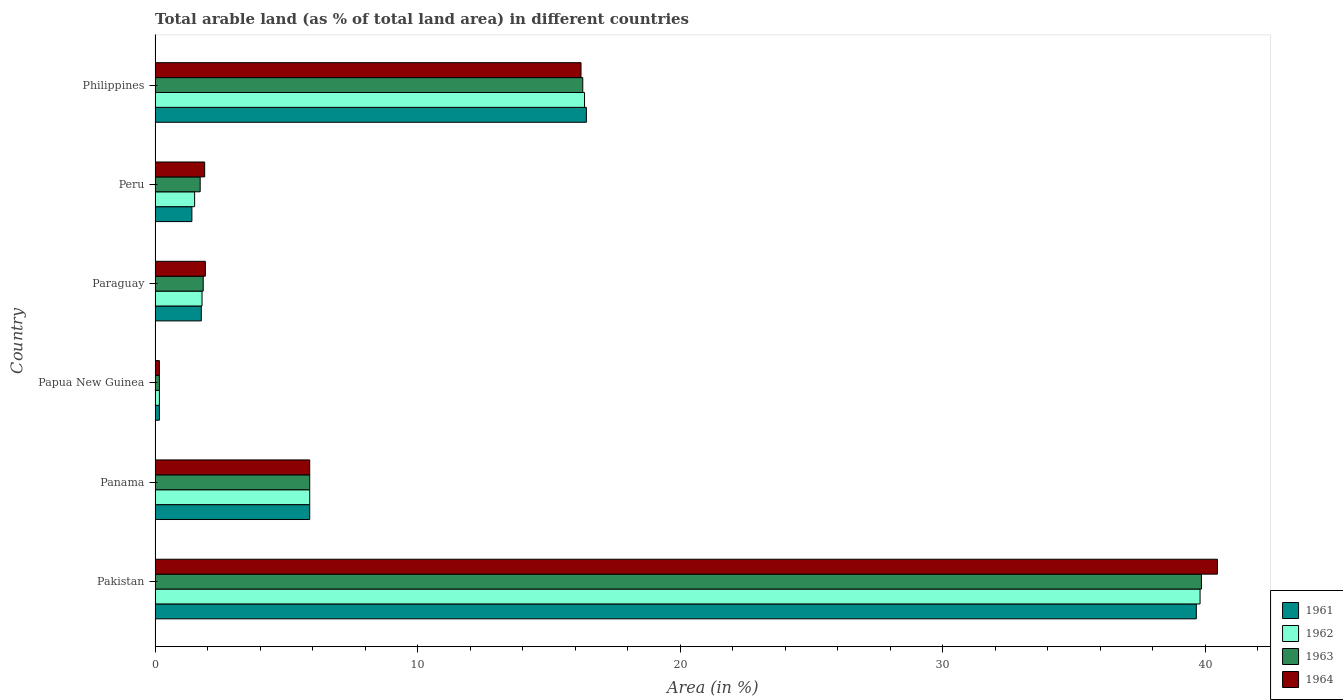How many groups of bars are there?
Ensure brevity in your answer.  6. Are the number of bars per tick equal to the number of legend labels?
Keep it short and to the point. Yes. How many bars are there on the 2nd tick from the bottom?
Ensure brevity in your answer.  4. What is the label of the 4th group of bars from the top?
Give a very brief answer. Papua New Guinea. In how many cases, is the number of bars for a given country not equal to the number of legend labels?
Offer a terse response. 0. What is the percentage of arable land in 1964 in Papua New Guinea?
Your answer should be compact. 0.17. Across all countries, what is the maximum percentage of arable land in 1964?
Provide a succinct answer. 40.47. Across all countries, what is the minimum percentage of arable land in 1961?
Provide a short and direct response. 0.17. In which country was the percentage of arable land in 1963 minimum?
Offer a very short reply. Papua New Guinea. What is the total percentage of arable land in 1961 in the graph?
Your response must be concise. 65.32. What is the difference between the percentage of arable land in 1961 in Pakistan and that in Papua New Guinea?
Provide a short and direct response. 39.5. What is the difference between the percentage of arable land in 1962 in Paraguay and the percentage of arable land in 1963 in Philippines?
Your answer should be very brief. -14.5. What is the average percentage of arable land in 1962 per country?
Provide a short and direct response. 10.92. What is the ratio of the percentage of arable land in 1964 in Pakistan to that in Paraguay?
Your response must be concise. 21.13. Is the percentage of arable land in 1963 in Peru less than that in Philippines?
Your answer should be compact. Yes. What is the difference between the highest and the second highest percentage of arable land in 1961?
Make the answer very short. 23.24. What is the difference between the highest and the lowest percentage of arable land in 1962?
Give a very brief answer. 39.65. In how many countries, is the percentage of arable land in 1964 greater than the average percentage of arable land in 1964 taken over all countries?
Your answer should be compact. 2. What does the 2nd bar from the top in Panama represents?
Your answer should be very brief. 1963. What does the 2nd bar from the bottom in Paraguay represents?
Provide a short and direct response. 1962. Is it the case that in every country, the sum of the percentage of arable land in 1963 and percentage of arable land in 1964 is greater than the percentage of arable land in 1961?
Make the answer very short. Yes. How many countries are there in the graph?
Offer a very short reply. 6. What is the difference between two consecutive major ticks on the X-axis?
Provide a short and direct response. 10. Where does the legend appear in the graph?
Ensure brevity in your answer.  Bottom right. How many legend labels are there?
Offer a very short reply. 4. How are the legend labels stacked?
Your answer should be compact. Vertical. What is the title of the graph?
Your answer should be very brief. Total arable land (as % of total land area) in different countries. Does "2010" appear as one of the legend labels in the graph?
Make the answer very short. No. What is the label or title of the X-axis?
Keep it short and to the point. Area (in %). What is the label or title of the Y-axis?
Provide a short and direct response. Country. What is the Area (in %) in 1961 in Pakistan?
Offer a terse response. 39.67. What is the Area (in %) in 1962 in Pakistan?
Provide a succinct answer. 39.81. What is the Area (in %) in 1963 in Pakistan?
Make the answer very short. 39.86. What is the Area (in %) in 1964 in Pakistan?
Your response must be concise. 40.47. What is the Area (in %) of 1961 in Panama?
Make the answer very short. 5.89. What is the Area (in %) of 1962 in Panama?
Offer a very short reply. 5.89. What is the Area (in %) of 1963 in Panama?
Provide a succinct answer. 5.89. What is the Area (in %) in 1964 in Panama?
Your answer should be compact. 5.89. What is the Area (in %) in 1961 in Papua New Guinea?
Offer a very short reply. 0.17. What is the Area (in %) of 1962 in Papua New Guinea?
Give a very brief answer. 0.17. What is the Area (in %) in 1963 in Papua New Guinea?
Ensure brevity in your answer.  0.17. What is the Area (in %) in 1964 in Papua New Guinea?
Your response must be concise. 0.17. What is the Area (in %) in 1961 in Paraguay?
Ensure brevity in your answer.  1.76. What is the Area (in %) in 1962 in Paraguay?
Make the answer very short. 1.79. What is the Area (in %) of 1963 in Paraguay?
Your answer should be very brief. 1.83. What is the Area (in %) in 1964 in Paraguay?
Offer a terse response. 1.92. What is the Area (in %) in 1961 in Peru?
Keep it short and to the point. 1.4. What is the Area (in %) of 1962 in Peru?
Your answer should be compact. 1.51. What is the Area (in %) of 1963 in Peru?
Make the answer very short. 1.72. What is the Area (in %) in 1964 in Peru?
Your response must be concise. 1.89. What is the Area (in %) of 1961 in Philippines?
Offer a terse response. 16.43. What is the Area (in %) of 1962 in Philippines?
Give a very brief answer. 16.36. What is the Area (in %) in 1963 in Philippines?
Offer a very short reply. 16.29. What is the Area (in %) in 1964 in Philippines?
Give a very brief answer. 16.23. Across all countries, what is the maximum Area (in %) of 1961?
Make the answer very short. 39.67. Across all countries, what is the maximum Area (in %) of 1962?
Give a very brief answer. 39.81. Across all countries, what is the maximum Area (in %) in 1963?
Ensure brevity in your answer.  39.86. Across all countries, what is the maximum Area (in %) of 1964?
Provide a short and direct response. 40.47. Across all countries, what is the minimum Area (in %) of 1961?
Provide a succinct answer. 0.17. Across all countries, what is the minimum Area (in %) of 1962?
Give a very brief answer. 0.17. Across all countries, what is the minimum Area (in %) in 1963?
Provide a succinct answer. 0.17. Across all countries, what is the minimum Area (in %) of 1964?
Keep it short and to the point. 0.17. What is the total Area (in %) in 1961 in the graph?
Ensure brevity in your answer.  65.32. What is the total Area (in %) in 1962 in the graph?
Your answer should be compact. 65.53. What is the total Area (in %) of 1963 in the graph?
Your response must be concise. 65.77. What is the total Area (in %) in 1964 in the graph?
Your response must be concise. 66.56. What is the difference between the Area (in %) of 1961 in Pakistan and that in Panama?
Give a very brief answer. 33.78. What is the difference between the Area (in %) in 1962 in Pakistan and that in Panama?
Make the answer very short. 33.92. What is the difference between the Area (in %) of 1963 in Pakistan and that in Panama?
Give a very brief answer. 33.97. What is the difference between the Area (in %) of 1964 in Pakistan and that in Panama?
Keep it short and to the point. 34.58. What is the difference between the Area (in %) in 1961 in Pakistan and that in Papua New Guinea?
Make the answer very short. 39.5. What is the difference between the Area (in %) in 1962 in Pakistan and that in Papua New Guinea?
Provide a succinct answer. 39.65. What is the difference between the Area (in %) in 1963 in Pakistan and that in Papua New Guinea?
Keep it short and to the point. 39.7. What is the difference between the Area (in %) in 1964 in Pakistan and that in Papua New Guinea?
Your answer should be compact. 40.31. What is the difference between the Area (in %) of 1961 in Pakistan and that in Paraguay?
Your answer should be compact. 37.91. What is the difference between the Area (in %) of 1962 in Pakistan and that in Paraguay?
Give a very brief answer. 38.02. What is the difference between the Area (in %) of 1963 in Pakistan and that in Paraguay?
Offer a very short reply. 38.03. What is the difference between the Area (in %) of 1964 in Pakistan and that in Paraguay?
Offer a terse response. 38.56. What is the difference between the Area (in %) in 1961 in Pakistan and that in Peru?
Offer a terse response. 38.27. What is the difference between the Area (in %) in 1962 in Pakistan and that in Peru?
Make the answer very short. 38.3. What is the difference between the Area (in %) in 1963 in Pakistan and that in Peru?
Make the answer very short. 38.14. What is the difference between the Area (in %) of 1964 in Pakistan and that in Peru?
Your answer should be compact. 38.58. What is the difference between the Area (in %) in 1961 in Pakistan and that in Philippines?
Your answer should be very brief. 23.24. What is the difference between the Area (in %) in 1962 in Pakistan and that in Philippines?
Your answer should be compact. 23.45. What is the difference between the Area (in %) of 1963 in Pakistan and that in Philippines?
Offer a very short reply. 23.57. What is the difference between the Area (in %) in 1964 in Pakistan and that in Philippines?
Your answer should be very brief. 24.25. What is the difference between the Area (in %) in 1961 in Panama and that in Papua New Guinea?
Your response must be concise. 5.73. What is the difference between the Area (in %) in 1962 in Panama and that in Papua New Guinea?
Your answer should be very brief. 5.73. What is the difference between the Area (in %) of 1963 in Panama and that in Papua New Guinea?
Your response must be concise. 5.73. What is the difference between the Area (in %) of 1964 in Panama and that in Papua New Guinea?
Keep it short and to the point. 5.73. What is the difference between the Area (in %) in 1961 in Panama and that in Paraguay?
Offer a terse response. 4.13. What is the difference between the Area (in %) of 1962 in Panama and that in Paraguay?
Keep it short and to the point. 4.1. What is the difference between the Area (in %) in 1963 in Panama and that in Paraguay?
Provide a succinct answer. 4.06. What is the difference between the Area (in %) of 1964 in Panama and that in Paraguay?
Your response must be concise. 3.98. What is the difference between the Area (in %) of 1961 in Panama and that in Peru?
Offer a very short reply. 4.49. What is the difference between the Area (in %) of 1962 in Panama and that in Peru?
Provide a short and direct response. 4.38. What is the difference between the Area (in %) of 1963 in Panama and that in Peru?
Keep it short and to the point. 4.17. What is the difference between the Area (in %) of 1964 in Panama and that in Peru?
Provide a succinct answer. 4. What is the difference between the Area (in %) in 1961 in Panama and that in Philippines?
Keep it short and to the point. -10.54. What is the difference between the Area (in %) of 1962 in Panama and that in Philippines?
Your answer should be very brief. -10.47. What is the difference between the Area (in %) of 1963 in Panama and that in Philippines?
Your answer should be very brief. -10.4. What is the difference between the Area (in %) of 1964 in Panama and that in Philippines?
Keep it short and to the point. -10.34. What is the difference between the Area (in %) in 1961 in Papua New Guinea and that in Paraguay?
Give a very brief answer. -1.6. What is the difference between the Area (in %) of 1962 in Papua New Guinea and that in Paraguay?
Your answer should be very brief. -1.62. What is the difference between the Area (in %) of 1963 in Papua New Guinea and that in Paraguay?
Ensure brevity in your answer.  -1.67. What is the difference between the Area (in %) of 1964 in Papua New Guinea and that in Paraguay?
Provide a succinct answer. -1.75. What is the difference between the Area (in %) of 1961 in Papua New Guinea and that in Peru?
Provide a succinct answer. -1.24. What is the difference between the Area (in %) of 1962 in Papua New Guinea and that in Peru?
Provide a short and direct response. -1.34. What is the difference between the Area (in %) in 1963 in Papua New Guinea and that in Peru?
Make the answer very short. -1.55. What is the difference between the Area (in %) in 1964 in Papua New Guinea and that in Peru?
Offer a very short reply. -1.72. What is the difference between the Area (in %) in 1961 in Papua New Guinea and that in Philippines?
Keep it short and to the point. -16.27. What is the difference between the Area (in %) of 1962 in Papua New Guinea and that in Philippines?
Your response must be concise. -16.2. What is the difference between the Area (in %) of 1963 in Papua New Guinea and that in Philippines?
Keep it short and to the point. -16.13. What is the difference between the Area (in %) of 1964 in Papua New Guinea and that in Philippines?
Ensure brevity in your answer.  -16.06. What is the difference between the Area (in %) in 1961 in Paraguay and that in Peru?
Your response must be concise. 0.36. What is the difference between the Area (in %) of 1962 in Paraguay and that in Peru?
Provide a succinct answer. 0.28. What is the difference between the Area (in %) in 1963 in Paraguay and that in Peru?
Ensure brevity in your answer.  0.12. What is the difference between the Area (in %) in 1964 in Paraguay and that in Peru?
Offer a very short reply. 0.03. What is the difference between the Area (in %) of 1961 in Paraguay and that in Philippines?
Provide a succinct answer. -14.67. What is the difference between the Area (in %) of 1962 in Paraguay and that in Philippines?
Offer a terse response. -14.57. What is the difference between the Area (in %) of 1963 in Paraguay and that in Philippines?
Give a very brief answer. -14.46. What is the difference between the Area (in %) of 1964 in Paraguay and that in Philippines?
Ensure brevity in your answer.  -14.31. What is the difference between the Area (in %) of 1961 in Peru and that in Philippines?
Keep it short and to the point. -15.03. What is the difference between the Area (in %) of 1962 in Peru and that in Philippines?
Make the answer very short. -14.85. What is the difference between the Area (in %) in 1963 in Peru and that in Philippines?
Provide a succinct answer. -14.58. What is the difference between the Area (in %) of 1964 in Peru and that in Philippines?
Your response must be concise. -14.34. What is the difference between the Area (in %) in 1961 in Pakistan and the Area (in %) in 1962 in Panama?
Offer a very short reply. 33.78. What is the difference between the Area (in %) of 1961 in Pakistan and the Area (in %) of 1963 in Panama?
Ensure brevity in your answer.  33.78. What is the difference between the Area (in %) in 1961 in Pakistan and the Area (in %) in 1964 in Panama?
Give a very brief answer. 33.78. What is the difference between the Area (in %) of 1962 in Pakistan and the Area (in %) of 1963 in Panama?
Make the answer very short. 33.92. What is the difference between the Area (in %) of 1962 in Pakistan and the Area (in %) of 1964 in Panama?
Give a very brief answer. 33.92. What is the difference between the Area (in %) in 1963 in Pakistan and the Area (in %) in 1964 in Panama?
Your response must be concise. 33.97. What is the difference between the Area (in %) in 1961 in Pakistan and the Area (in %) in 1962 in Papua New Guinea?
Offer a terse response. 39.5. What is the difference between the Area (in %) in 1961 in Pakistan and the Area (in %) in 1963 in Papua New Guinea?
Ensure brevity in your answer.  39.5. What is the difference between the Area (in %) in 1961 in Pakistan and the Area (in %) in 1964 in Papua New Guinea?
Keep it short and to the point. 39.5. What is the difference between the Area (in %) in 1962 in Pakistan and the Area (in %) in 1963 in Papua New Guinea?
Offer a terse response. 39.65. What is the difference between the Area (in %) of 1962 in Pakistan and the Area (in %) of 1964 in Papua New Guinea?
Your answer should be compact. 39.65. What is the difference between the Area (in %) in 1963 in Pakistan and the Area (in %) in 1964 in Papua New Guinea?
Your answer should be very brief. 39.7. What is the difference between the Area (in %) in 1961 in Pakistan and the Area (in %) in 1962 in Paraguay?
Provide a succinct answer. 37.88. What is the difference between the Area (in %) in 1961 in Pakistan and the Area (in %) in 1963 in Paraguay?
Give a very brief answer. 37.83. What is the difference between the Area (in %) in 1961 in Pakistan and the Area (in %) in 1964 in Paraguay?
Offer a terse response. 37.75. What is the difference between the Area (in %) in 1962 in Pakistan and the Area (in %) in 1963 in Paraguay?
Provide a succinct answer. 37.98. What is the difference between the Area (in %) of 1962 in Pakistan and the Area (in %) of 1964 in Paraguay?
Keep it short and to the point. 37.9. What is the difference between the Area (in %) of 1963 in Pakistan and the Area (in %) of 1964 in Paraguay?
Provide a succinct answer. 37.95. What is the difference between the Area (in %) in 1961 in Pakistan and the Area (in %) in 1962 in Peru?
Make the answer very short. 38.16. What is the difference between the Area (in %) of 1961 in Pakistan and the Area (in %) of 1963 in Peru?
Give a very brief answer. 37.95. What is the difference between the Area (in %) in 1961 in Pakistan and the Area (in %) in 1964 in Peru?
Provide a short and direct response. 37.78. What is the difference between the Area (in %) of 1962 in Pakistan and the Area (in %) of 1963 in Peru?
Your answer should be very brief. 38.09. What is the difference between the Area (in %) in 1962 in Pakistan and the Area (in %) in 1964 in Peru?
Provide a short and direct response. 37.92. What is the difference between the Area (in %) of 1963 in Pakistan and the Area (in %) of 1964 in Peru?
Your answer should be very brief. 37.97. What is the difference between the Area (in %) in 1961 in Pakistan and the Area (in %) in 1962 in Philippines?
Your answer should be very brief. 23.31. What is the difference between the Area (in %) of 1961 in Pakistan and the Area (in %) of 1963 in Philippines?
Offer a very short reply. 23.37. What is the difference between the Area (in %) in 1961 in Pakistan and the Area (in %) in 1964 in Philippines?
Provide a short and direct response. 23.44. What is the difference between the Area (in %) of 1962 in Pakistan and the Area (in %) of 1963 in Philippines?
Ensure brevity in your answer.  23.52. What is the difference between the Area (in %) of 1962 in Pakistan and the Area (in %) of 1964 in Philippines?
Provide a short and direct response. 23.58. What is the difference between the Area (in %) in 1963 in Pakistan and the Area (in %) in 1964 in Philippines?
Provide a short and direct response. 23.64. What is the difference between the Area (in %) of 1961 in Panama and the Area (in %) of 1962 in Papua New Guinea?
Your answer should be compact. 5.73. What is the difference between the Area (in %) of 1961 in Panama and the Area (in %) of 1963 in Papua New Guinea?
Provide a short and direct response. 5.73. What is the difference between the Area (in %) in 1961 in Panama and the Area (in %) in 1964 in Papua New Guinea?
Make the answer very short. 5.73. What is the difference between the Area (in %) of 1962 in Panama and the Area (in %) of 1963 in Papua New Guinea?
Offer a terse response. 5.73. What is the difference between the Area (in %) of 1962 in Panama and the Area (in %) of 1964 in Papua New Guinea?
Your answer should be compact. 5.73. What is the difference between the Area (in %) of 1963 in Panama and the Area (in %) of 1964 in Papua New Guinea?
Ensure brevity in your answer.  5.73. What is the difference between the Area (in %) in 1961 in Panama and the Area (in %) in 1962 in Paraguay?
Your answer should be compact. 4.1. What is the difference between the Area (in %) in 1961 in Panama and the Area (in %) in 1963 in Paraguay?
Offer a terse response. 4.06. What is the difference between the Area (in %) in 1961 in Panama and the Area (in %) in 1964 in Paraguay?
Provide a succinct answer. 3.98. What is the difference between the Area (in %) in 1962 in Panama and the Area (in %) in 1963 in Paraguay?
Your answer should be compact. 4.06. What is the difference between the Area (in %) of 1962 in Panama and the Area (in %) of 1964 in Paraguay?
Ensure brevity in your answer.  3.98. What is the difference between the Area (in %) in 1963 in Panama and the Area (in %) in 1964 in Paraguay?
Ensure brevity in your answer.  3.98. What is the difference between the Area (in %) in 1961 in Panama and the Area (in %) in 1962 in Peru?
Your answer should be compact. 4.38. What is the difference between the Area (in %) of 1961 in Panama and the Area (in %) of 1963 in Peru?
Make the answer very short. 4.17. What is the difference between the Area (in %) of 1961 in Panama and the Area (in %) of 1964 in Peru?
Make the answer very short. 4. What is the difference between the Area (in %) of 1962 in Panama and the Area (in %) of 1963 in Peru?
Offer a very short reply. 4.17. What is the difference between the Area (in %) of 1962 in Panama and the Area (in %) of 1964 in Peru?
Keep it short and to the point. 4. What is the difference between the Area (in %) in 1963 in Panama and the Area (in %) in 1964 in Peru?
Ensure brevity in your answer.  4. What is the difference between the Area (in %) in 1961 in Panama and the Area (in %) in 1962 in Philippines?
Your response must be concise. -10.47. What is the difference between the Area (in %) of 1961 in Panama and the Area (in %) of 1963 in Philippines?
Your answer should be very brief. -10.4. What is the difference between the Area (in %) of 1961 in Panama and the Area (in %) of 1964 in Philippines?
Your answer should be very brief. -10.34. What is the difference between the Area (in %) of 1962 in Panama and the Area (in %) of 1963 in Philippines?
Offer a very short reply. -10.4. What is the difference between the Area (in %) of 1962 in Panama and the Area (in %) of 1964 in Philippines?
Give a very brief answer. -10.34. What is the difference between the Area (in %) of 1963 in Panama and the Area (in %) of 1964 in Philippines?
Your answer should be compact. -10.34. What is the difference between the Area (in %) of 1961 in Papua New Guinea and the Area (in %) of 1962 in Paraguay?
Your answer should be compact. -1.62. What is the difference between the Area (in %) in 1961 in Papua New Guinea and the Area (in %) in 1963 in Paraguay?
Offer a terse response. -1.67. What is the difference between the Area (in %) of 1961 in Papua New Guinea and the Area (in %) of 1964 in Paraguay?
Keep it short and to the point. -1.75. What is the difference between the Area (in %) of 1962 in Papua New Guinea and the Area (in %) of 1963 in Paraguay?
Give a very brief answer. -1.67. What is the difference between the Area (in %) of 1962 in Papua New Guinea and the Area (in %) of 1964 in Paraguay?
Provide a succinct answer. -1.75. What is the difference between the Area (in %) of 1963 in Papua New Guinea and the Area (in %) of 1964 in Paraguay?
Provide a short and direct response. -1.75. What is the difference between the Area (in %) in 1961 in Papua New Guinea and the Area (in %) in 1962 in Peru?
Ensure brevity in your answer.  -1.34. What is the difference between the Area (in %) of 1961 in Papua New Guinea and the Area (in %) of 1963 in Peru?
Your answer should be compact. -1.55. What is the difference between the Area (in %) of 1961 in Papua New Guinea and the Area (in %) of 1964 in Peru?
Your answer should be compact. -1.72. What is the difference between the Area (in %) in 1962 in Papua New Guinea and the Area (in %) in 1963 in Peru?
Give a very brief answer. -1.55. What is the difference between the Area (in %) of 1962 in Papua New Guinea and the Area (in %) of 1964 in Peru?
Offer a terse response. -1.72. What is the difference between the Area (in %) of 1963 in Papua New Guinea and the Area (in %) of 1964 in Peru?
Keep it short and to the point. -1.72. What is the difference between the Area (in %) in 1961 in Papua New Guinea and the Area (in %) in 1962 in Philippines?
Offer a terse response. -16.2. What is the difference between the Area (in %) in 1961 in Papua New Guinea and the Area (in %) in 1963 in Philippines?
Offer a terse response. -16.13. What is the difference between the Area (in %) in 1961 in Papua New Guinea and the Area (in %) in 1964 in Philippines?
Offer a terse response. -16.06. What is the difference between the Area (in %) of 1962 in Papua New Guinea and the Area (in %) of 1963 in Philippines?
Your answer should be compact. -16.13. What is the difference between the Area (in %) of 1962 in Papua New Guinea and the Area (in %) of 1964 in Philippines?
Keep it short and to the point. -16.06. What is the difference between the Area (in %) of 1963 in Papua New Guinea and the Area (in %) of 1964 in Philippines?
Your answer should be compact. -16.06. What is the difference between the Area (in %) in 1961 in Paraguay and the Area (in %) in 1962 in Peru?
Provide a short and direct response. 0.25. What is the difference between the Area (in %) in 1961 in Paraguay and the Area (in %) in 1963 in Peru?
Give a very brief answer. 0.04. What is the difference between the Area (in %) in 1961 in Paraguay and the Area (in %) in 1964 in Peru?
Your answer should be compact. -0.13. What is the difference between the Area (in %) of 1962 in Paraguay and the Area (in %) of 1963 in Peru?
Provide a succinct answer. 0.07. What is the difference between the Area (in %) in 1962 in Paraguay and the Area (in %) in 1964 in Peru?
Keep it short and to the point. -0.1. What is the difference between the Area (in %) of 1963 in Paraguay and the Area (in %) of 1964 in Peru?
Provide a succinct answer. -0.06. What is the difference between the Area (in %) in 1961 in Paraguay and the Area (in %) in 1962 in Philippines?
Provide a succinct answer. -14.6. What is the difference between the Area (in %) of 1961 in Paraguay and the Area (in %) of 1963 in Philippines?
Provide a succinct answer. -14.53. What is the difference between the Area (in %) of 1961 in Paraguay and the Area (in %) of 1964 in Philippines?
Ensure brevity in your answer.  -14.47. What is the difference between the Area (in %) in 1962 in Paraguay and the Area (in %) in 1963 in Philippines?
Ensure brevity in your answer.  -14.5. What is the difference between the Area (in %) in 1962 in Paraguay and the Area (in %) in 1964 in Philippines?
Give a very brief answer. -14.44. What is the difference between the Area (in %) in 1963 in Paraguay and the Area (in %) in 1964 in Philippines?
Give a very brief answer. -14.39. What is the difference between the Area (in %) of 1961 in Peru and the Area (in %) of 1962 in Philippines?
Offer a very short reply. -14.96. What is the difference between the Area (in %) of 1961 in Peru and the Area (in %) of 1963 in Philippines?
Your answer should be compact. -14.89. What is the difference between the Area (in %) in 1961 in Peru and the Area (in %) in 1964 in Philippines?
Make the answer very short. -14.82. What is the difference between the Area (in %) of 1962 in Peru and the Area (in %) of 1963 in Philippines?
Offer a terse response. -14.79. What is the difference between the Area (in %) in 1962 in Peru and the Area (in %) in 1964 in Philippines?
Give a very brief answer. -14.72. What is the difference between the Area (in %) in 1963 in Peru and the Area (in %) in 1964 in Philippines?
Provide a succinct answer. -14.51. What is the average Area (in %) in 1961 per country?
Offer a very short reply. 10.89. What is the average Area (in %) of 1962 per country?
Ensure brevity in your answer.  10.92. What is the average Area (in %) in 1963 per country?
Offer a very short reply. 10.96. What is the average Area (in %) in 1964 per country?
Keep it short and to the point. 11.09. What is the difference between the Area (in %) in 1961 and Area (in %) in 1962 in Pakistan?
Make the answer very short. -0.14. What is the difference between the Area (in %) of 1961 and Area (in %) of 1963 in Pakistan?
Offer a terse response. -0.19. What is the difference between the Area (in %) of 1961 and Area (in %) of 1964 in Pakistan?
Your answer should be very brief. -0.8. What is the difference between the Area (in %) of 1962 and Area (in %) of 1963 in Pakistan?
Provide a succinct answer. -0.05. What is the difference between the Area (in %) of 1962 and Area (in %) of 1964 in Pakistan?
Ensure brevity in your answer.  -0.66. What is the difference between the Area (in %) of 1963 and Area (in %) of 1964 in Pakistan?
Offer a very short reply. -0.61. What is the difference between the Area (in %) of 1961 and Area (in %) of 1962 in Panama?
Your answer should be compact. 0. What is the difference between the Area (in %) in 1961 and Area (in %) in 1963 in Panama?
Your response must be concise. 0. What is the difference between the Area (in %) of 1961 and Area (in %) of 1964 in Panama?
Provide a succinct answer. 0. What is the difference between the Area (in %) in 1961 and Area (in %) in 1962 in Papua New Guinea?
Make the answer very short. 0. What is the difference between the Area (in %) of 1961 and Area (in %) of 1963 in Papua New Guinea?
Your answer should be compact. 0. What is the difference between the Area (in %) of 1961 and Area (in %) of 1962 in Paraguay?
Offer a terse response. -0.03. What is the difference between the Area (in %) of 1961 and Area (in %) of 1963 in Paraguay?
Offer a terse response. -0.07. What is the difference between the Area (in %) in 1961 and Area (in %) in 1964 in Paraguay?
Your answer should be very brief. -0.15. What is the difference between the Area (in %) in 1962 and Area (in %) in 1963 in Paraguay?
Provide a succinct answer. -0.05. What is the difference between the Area (in %) of 1962 and Area (in %) of 1964 in Paraguay?
Your answer should be very brief. -0.13. What is the difference between the Area (in %) in 1963 and Area (in %) in 1964 in Paraguay?
Give a very brief answer. -0.08. What is the difference between the Area (in %) in 1961 and Area (in %) in 1962 in Peru?
Provide a succinct answer. -0.1. What is the difference between the Area (in %) in 1961 and Area (in %) in 1963 in Peru?
Offer a terse response. -0.32. What is the difference between the Area (in %) of 1961 and Area (in %) of 1964 in Peru?
Keep it short and to the point. -0.49. What is the difference between the Area (in %) in 1962 and Area (in %) in 1963 in Peru?
Make the answer very short. -0.21. What is the difference between the Area (in %) of 1962 and Area (in %) of 1964 in Peru?
Provide a short and direct response. -0.38. What is the difference between the Area (in %) in 1963 and Area (in %) in 1964 in Peru?
Keep it short and to the point. -0.17. What is the difference between the Area (in %) of 1961 and Area (in %) of 1962 in Philippines?
Your answer should be very brief. 0.07. What is the difference between the Area (in %) in 1961 and Area (in %) in 1963 in Philippines?
Keep it short and to the point. 0.14. What is the difference between the Area (in %) in 1961 and Area (in %) in 1964 in Philippines?
Make the answer very short. 0.2. What is the difference between the Area (in %) in 1962 and Area (in %) in 1963 in Philippines?
Make the answer very short. 0.07. What is the difference between the Area (in %) in 1962 and Area (in %) in 1964 in Philippines?
Ensure brevity in your answer.  0.13. What is the difference between the Area (in %) in 1963 and Area (in %) in 1964 in Philippines?
Provide a short and direct response. 0.07. What is the ratio of the Area (in %) of 1961 in Pakistan to that in Panama?
Keep it short and to the point. 6.73. What is the ratio of the Area (in %) in 1962 in Pakistan to that in Panama?
Keep it short and to the point. 6.76. What is the ratio of the Area (in %) of 1963 in Pakistan to that in Panama?
Your answer should be compact. 6.77. What is the ratio of the Area (in %) in 1964 in Pakistan to that in Panama?
Offer a very short reply. 6.87. What is the ratio of the Area (in %) in 1961 in Pakistan to that in Papua New Guinea?
Ensure brevity in your answer.  239.53. What is the ratio of the Area (in %) in 1962 in Pakistan to that in Papua New Guinea?
Your answer should be very brief. 240.39. What is the ratio of the Area (in %) of 1963 in Pakistan to that in Papua New Guinea?
Make the answer very short. 240.7. What is the ratio of the Area (in %) of 1964 in Pakistan to that in Papua New Guinea?
Your answer should be very brief. 244.38. What is the ratio of the Area (in %) of 1961 in Pakistan to that in Paraguay?
Provide a succinct answer. 22.52. What is the ratio of the Area (in %) of 1962 in Pakistan to that in Paraguay?
Give a very brief answer. 22.25. What is the ratio of the Area (in %) of 1963 in Pakistan to that in Paraguay?
Ensure brevity in your answer.  21.73. What is the ratio of the Area (in %) of 1964 in Pakistan to that in Paraguay?
Your response must be concise. 21.13. What is the ratio of the Area (in %) in 1961 in Pakistan to that in Peru?
Ensure brevity in your answer.  28.27. What is the ratio of the Area (in %) of 1962 in Pakistan to that in Peru?
Make the answer very short. 26.42. What is the ratio of the Area (in %) of 1963 in Pakistan to that in Peru?
Offer a terse response. 23.19. What is the ratio of the Area (in %) in 1964 in Pakistan to that in Peru?
Make the answer very short. 21.42. What is the ratio of the Area (in %) of 1961 in Pakistan to that in Philippines?
Offer a terse response. 2.41. What is the ratio of the Area (in %) in 1962 in Pakistan to that in Philippines?
Ensure brevity in your answer.  2.43. What is the ratio of the Area (in %) of 1963 in Pakistan to that in Philippines?
Provide a short and direct response. 2.45. What is the ratio of the Area (in %) of 1964 in Pakistan to that in Philippines?
Give a very brief answer. 2.49. What is the ratio of the Area (in %) in 1961 in Panama to that in Papua New Guinea?
Offer a very short reply. 35.58. What is the ratio of the Area (in %) in 1962 in Panama to that in Papua New Guinea?
Offer a terse response. 35.58. What is the ratio of the Area (in %) of 1963 in Panama to that in Papua New Guinea?
Make the answer very short. 35.58. What is the ratio of the Area (in %) in 1964 in Panama to that in Papua New Guinea?
Keep it short and to the point. 35.58. What is the ratio of the Area (in %) of 1961 in Panama to that in Paraguay?
Make the answer very short. 3.34. What is the ratio of the Area (in %) of 1962 in Panama to that in Paraguay?
Your response must be concise. 3.29. What is the ratio of the Area (in %) in 1963 in Panama to that in Paraguay?
Ensure brevity in your answer.  3.21. What is the ratio of the Area (in %) in 1964 in Panama to that in Paraguay?
Your answer should be very brief. 3.08. What is the ratio of the Area (in %) in 1961 in Panama to that in Peru?
Offer a terse response. 4.2. What is the ratio of the Area (in %) of 1962 in Panama to that in Peru?
Provide a short and direct response. 3.91. What is the ratio of the Area (in %) of 1963 in Panama to that in Peru?
Make the answer very short. 3.43. What is the ratio of the Area (in %) in 1964 in Panama to that in Peru?
Make the answer very short. 3.12. What is the ratio of the Area (in %) of 1961 in Panama to that in Philippines?
Give a very brief answer. 0.36. What is the ratio of the Area (in %) of 1962 in Panama to that in Philippines?
Your answer should be very brief. 0.36. What is the ratio of the Area (in %) in 1963 in Panama to that in Philippines?
Your answer should be very brief. 0.36. What is the ratio of the Area (in %) of 1964 in Panama to that in Philippines?
Your answer should be very brief. 0.36. What is the ratio of the Area (in %) in 1961 in Papua New Guinea to that in Paraguay?
Your answer should be compact. 0.09. What is the ratio of the Area (in %) in 1962 in Papua New Guinea to that in Paraguay?
Offer a terse response. 0.09. What is the ratio of the Area (in %) of 1963 in Papua New Guinea to that in Paraguay?
Offer a very short reply. 0.09. What is the ratio of the Area (in %) of 1964 in Papua New Guinea to that in Paraguay?
Give a very brief answer. 0.09. What is the ratio of the Area (in %) in 1961 in Papua New Guinea to that in Peru?
Your response must be concise. 0.12. What is the ratio of the Area (in %) in 1962 in Papua New Guinea to that in Peru?
Keep it short and to the point. 0.11. What is the ratio of the Area (in %) of 1963 in Papua New Guinea to that in Peru?
Offer a terse response. 0.1. What is the ratio of the Area (in %) of 1964 in Papua New Guinea to that in Peru?
Provide a succinct answer. 0.09. What is the ratio of the Area (in %) in 1961 in Papua New Guinea to that in Philippines?
Offer a very short reply. 0.01. What is the ratio of the Area (in %) in 1962 in Papua New Guinea to that in Philippines?
Provide a succinct answer. 0.01. What is the ratio of the Area (in %) in 1963 in Papua New Guinea to that in Philippines?
Give a very brief answer. 0.01. What is the ratio of the Area (in %) of 1964 in Papua New Guinea to that in Philippines?
Offer a very short reply. 0.01. What is the ratio of the Area (in %) of 1961 in Paraguay to that in Peru?
Your answer should be very brief. 1.26. What is the ratio of the Area (in %) of 1962 in Paraguay to that in Peru?
Ensure brevity in your answer.  1.19. What is the ratio of the Area (in %) in 1963 in Paraguay to that in Peru?
Keep it short and to the point. 1.07. What is the ratio of the Area (in %) in 1964 in Paraguay to that in Peru?
Your response must be concise. 1.01. What is the ratio of the Area (in %) of 1961 in Paraguay to that in Philippines?
Your answer should be compact. 0.11. What is the ratio of the Area (in %) in 1962 in Paraguay to that in Philippines?
Offer a terse response. 0.11. What is the ratio of the Area (in %) of 1963 in Paraguay to that in Philippines?
Give a very brief answer. 0.11. What is the ratio of the Area (in %) of 1964 in Paraguay to that in Philippines?
Offer a terse response. 0.12. What is the ratio of the Area (in %) in 1961 in Peru to that in Philippines?
Provide a succinct answer. 0.09. What is the ratio of the Area (in %) of 1962 in Peru to that in Philippines?
Offer a terse response. 0.09. What is the ratio of the Area (in %) in 1963 in Peru to that in Philippines?
Ensure brevity in your answer.  0.11. What is the ratio of the Area (in %) of 1964 in Peru to that in Philippines?
Offer a very short reply. 0.12. What is the difference between the highest and the second highest Area (in %) of 1961?
Make the answer very short. 23.24. What is the difference between the highest and the second highest Area (in %) in 1962?
Your response must be concise. 23.45. What is the difference between the highest and the second highest Area (in %) in 1963?
Your answer should be compact. 23.57. What is the difference between the highest and the second highest Area (in %) in 1964?
Ensure brevity in your answer.  24.25. What is the difference between the highest and the lowest Area (in %) of 1961?
Provide a short and direct response. 39.5. What is the difference between the highest and the lowest Area (in %) in 1962?
Provide a short and direct response. 39.65. What is the difference between the highest and the lowest Area (in %) in 1963?
Your response must be concise. 39.7. What is the difference between the highest and the lowest Area (in %) of 1964?
Ensure brevity in your answer.  40.31. 